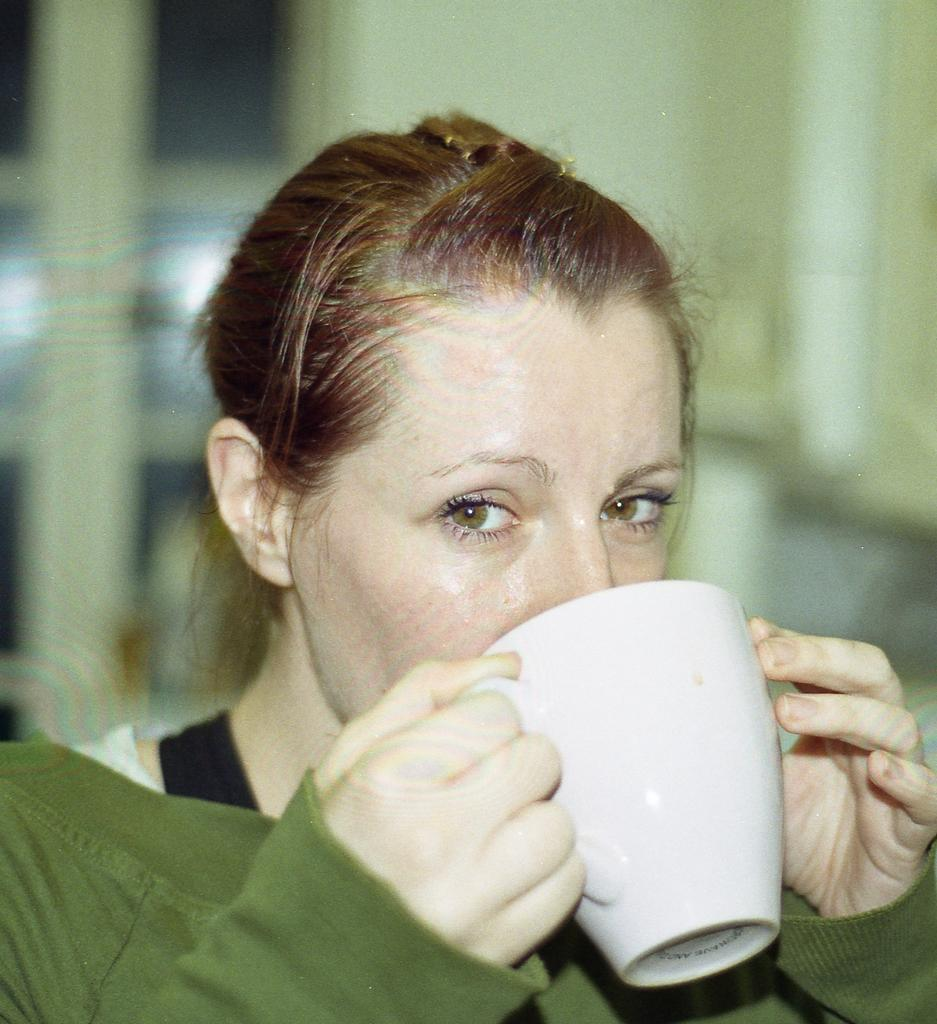Who is present in the image? There is a person in the image. What is the person doing in the image? The person is looking at a side. What object is the person holding in the image? The person is holding a cup. How does the person increase the temperature of the cup in the image? There is no indication in the image that the person is trying to increase the temperature of the cup, nor is there any visible method for doing so. 